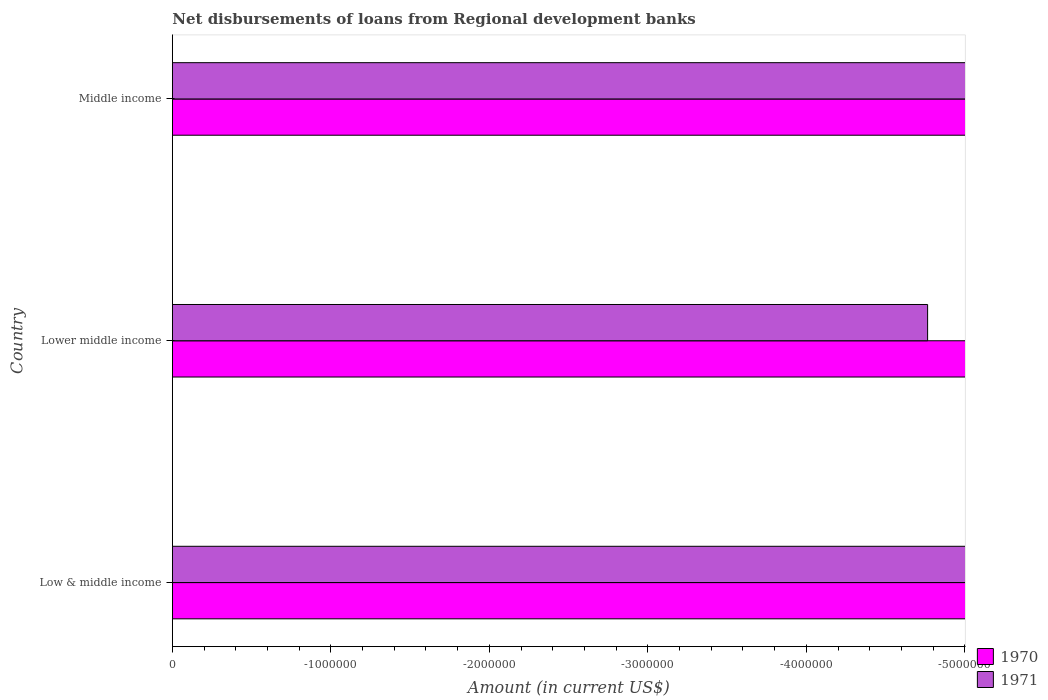Are the number of bars per tick equal to the number of legend labels?
Your answer should be compact. No. How many bars are there on the 1st tick from the top?
Your response must be concise. 0. How many bars are there on the 2nd tick from the bottom?
Provide a short and direct response. 0. What is the label of the 1st group of bars from the top?
Your response must be concise. Middle income. In how many cases, is the number of bars for a given country not equal to the number of legend labels?
Make the answer very short. 3. Across all countries, what is the minimum amount of disbursements of loans from regional development banks in 1970?
Your answer should be very brief. 0. What is the total amount of disbursements of loans from regional development banks in 1970 in the graph?
Provide a succinct answer. 0. How many bars are there?
Offer a terse response. 0. Are all the bars in the graph horizontal?
Your answer should be very brief. Yes. What is the difference between two consecutive major ticks on the X-axis?
Your answer should be very brief. 1.00e+06. What is the title of the graph?
Offer a terse response. Net disbursements of loans from Regional development banks. Does "1979" appear as one of the legend labels in the graph?
Your response must be concise. No. What is the label or title of the X-axis?
Keep it short and to the point. Amount (in current US$). What is the Amount (in current US$) of 1970 in Low & middle income?
Provide a short and direct response. 0. What is the total Amount (in current US$) in 1970 in the graph?
Provide a short and direct response. 0. What is the total Amount (in current US$) in 1971 in the graph?
Provide a succinct answer. 0. What is the average Amount (in current US$) of 1970 per country?
Offer a very short reply. 0. 